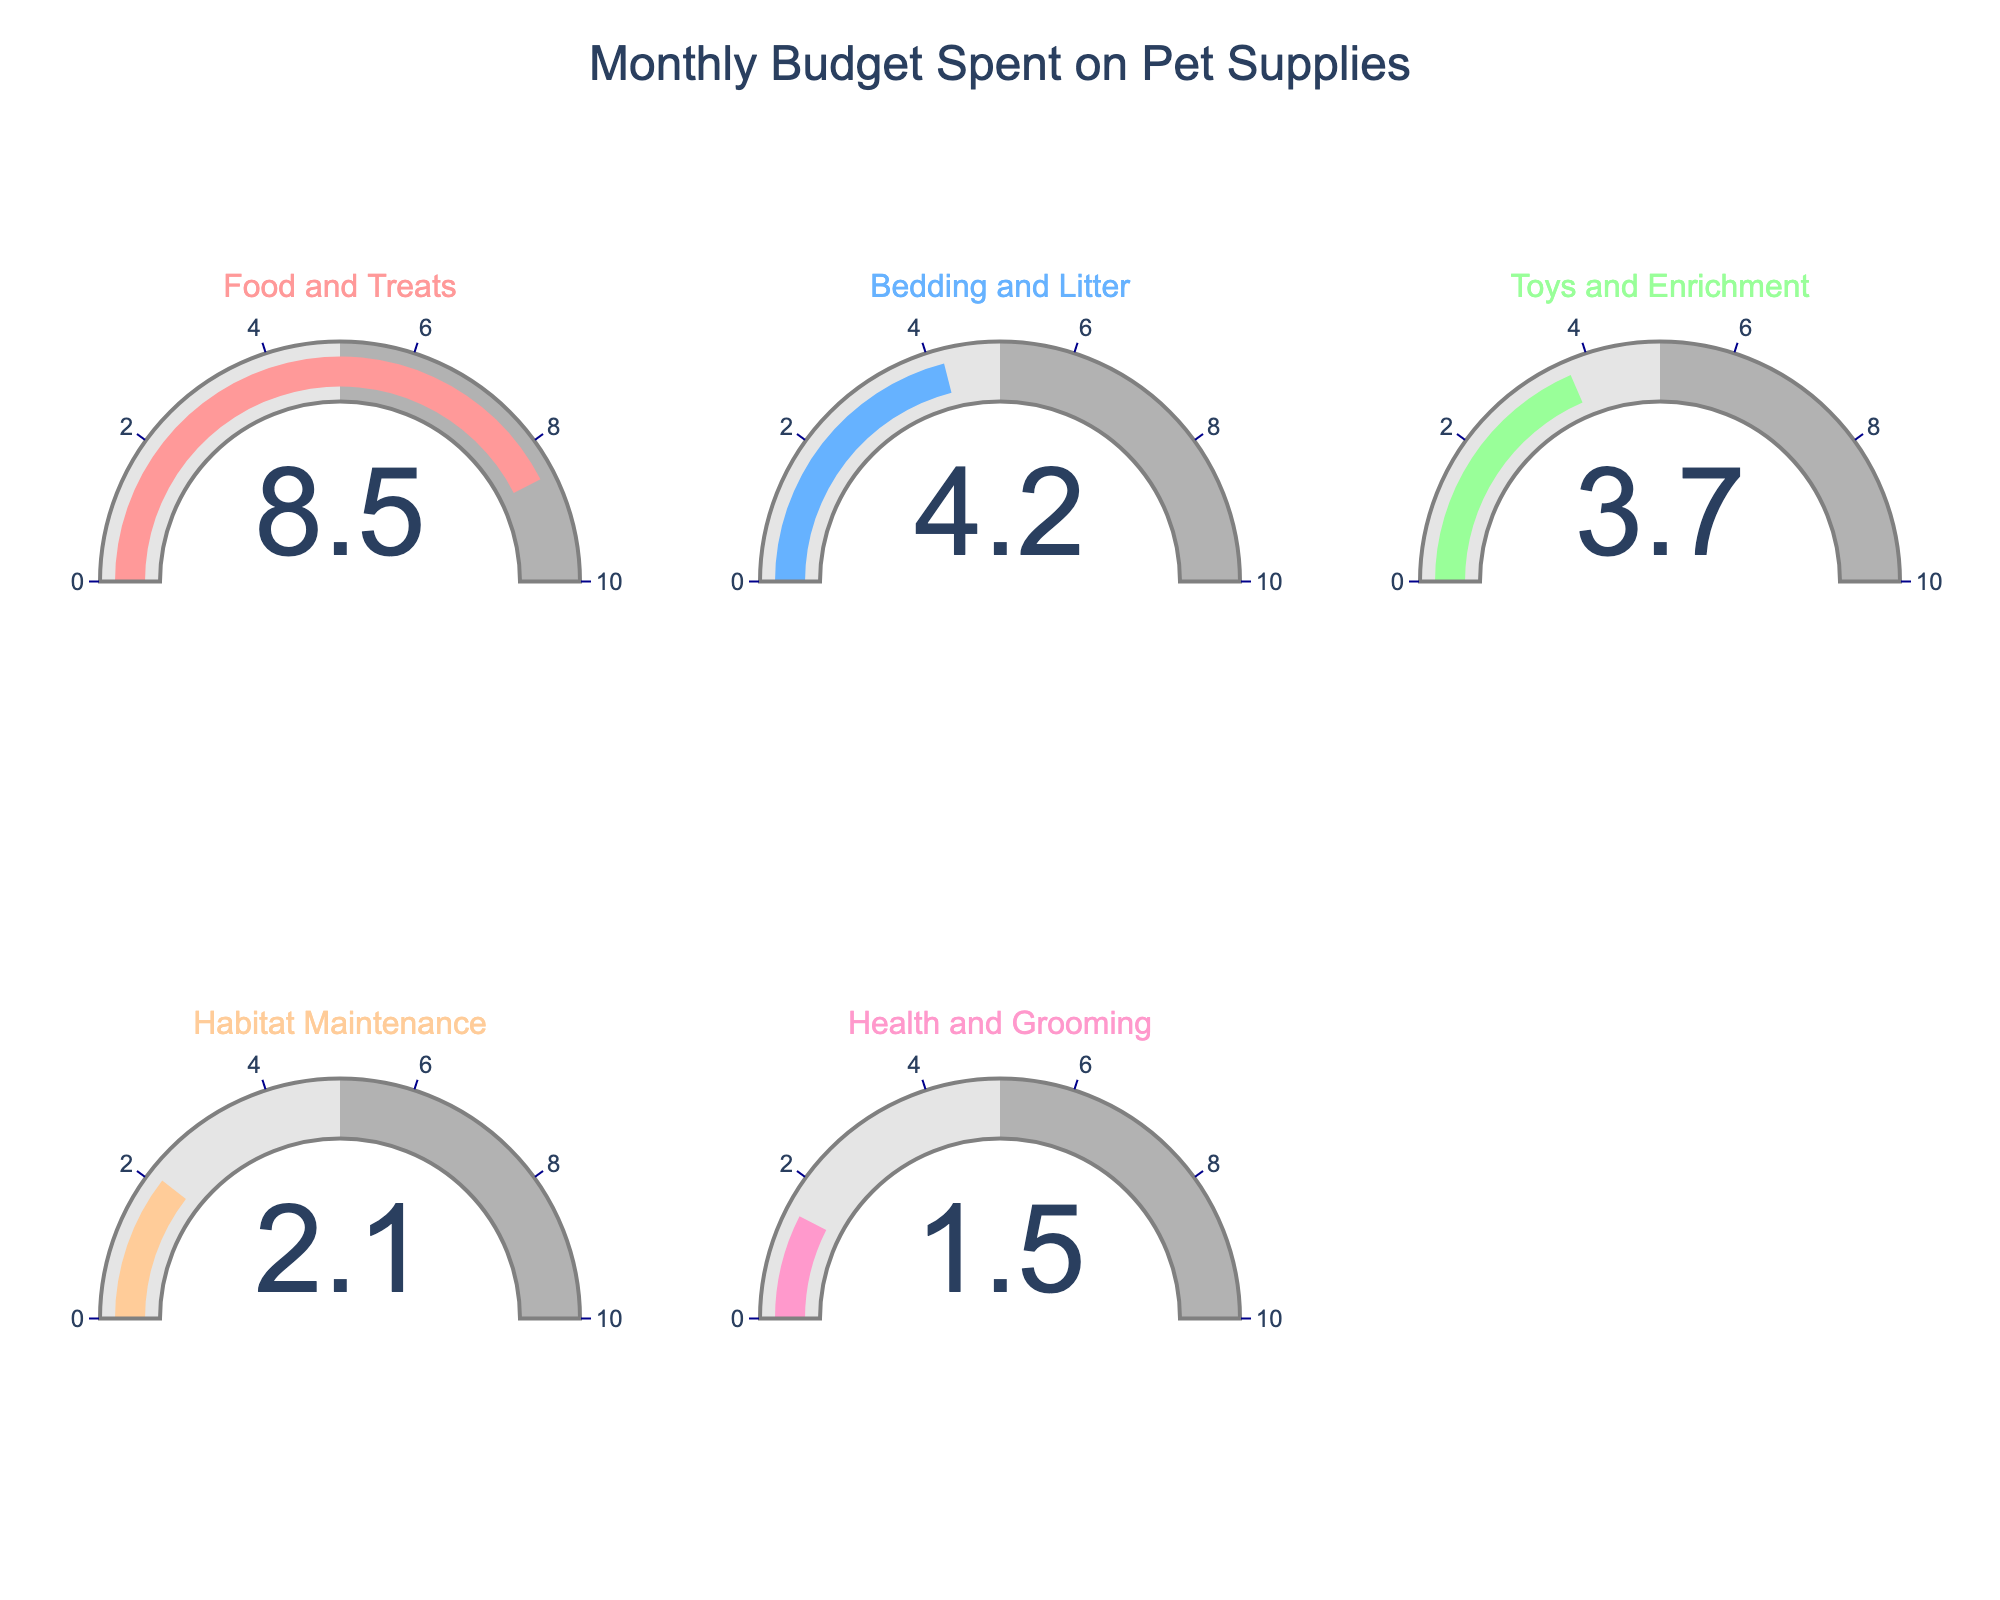What's the percentage of the monthly budget spent on Food and Treats? Look at the gauge displaying "Food and Treats" and note the percentage value indicated.
Answer: 8.5% Which category has the lowest percentage of monthly budget spent? Identify the gauge with the lowest value among all five categories.
Answer: Health and Grooming What is the total percentage spent on Bedding and Litter and Toys and Enrichment combined? Add the percentages of Bedding and Litter (4.2%) and Toys and Enrichment (3.7%).
Answer: 7.9% Which category is closer to the 5% mark on the gauge? Compare the listed percentages of all categories to see which one is nearest to 5%.
Answer: Bedding and Litter What is the difference in percentage between Food and Treats and Habitat Maintenance? Subtract the percentage of Habitat Maintenance (2.1%) from Food and Treats (8.5%).
Answer: 6.4% What is the average percentage of the monthly budget spent across all categories? Sum up all the percentages (8.5% + 4.2% + 3.7% + 2.1% + 1.5%) and then divide by the number of categories (5).
Answer: 4% How much more is spent on Toys and Enrichment compared to Health and Grooming? Subtract the percentage of Health and Grooming (1.5%) from Toys and Enrichment (3.7%).
Answer: 2.2% Which category's gauge has the most pronounced color contrast within its range? Observe the gauge colors and determine which gauge has the highest contrast between its segments and the indicator bar.
Answer: Subjective, but likely to be Food and Treats or Bedding and Litter (based on color description and range placement) 